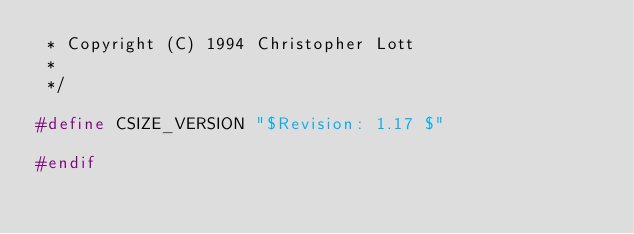Convert code to text. <code><loc_0><loc_0><loc_500><loc_500><_C_> * Copyright (C) 1994 Christopher Lott
 *
 */

#define CSIZE_VERSION "$Revision: 1.17 $"

#endif
</code> 